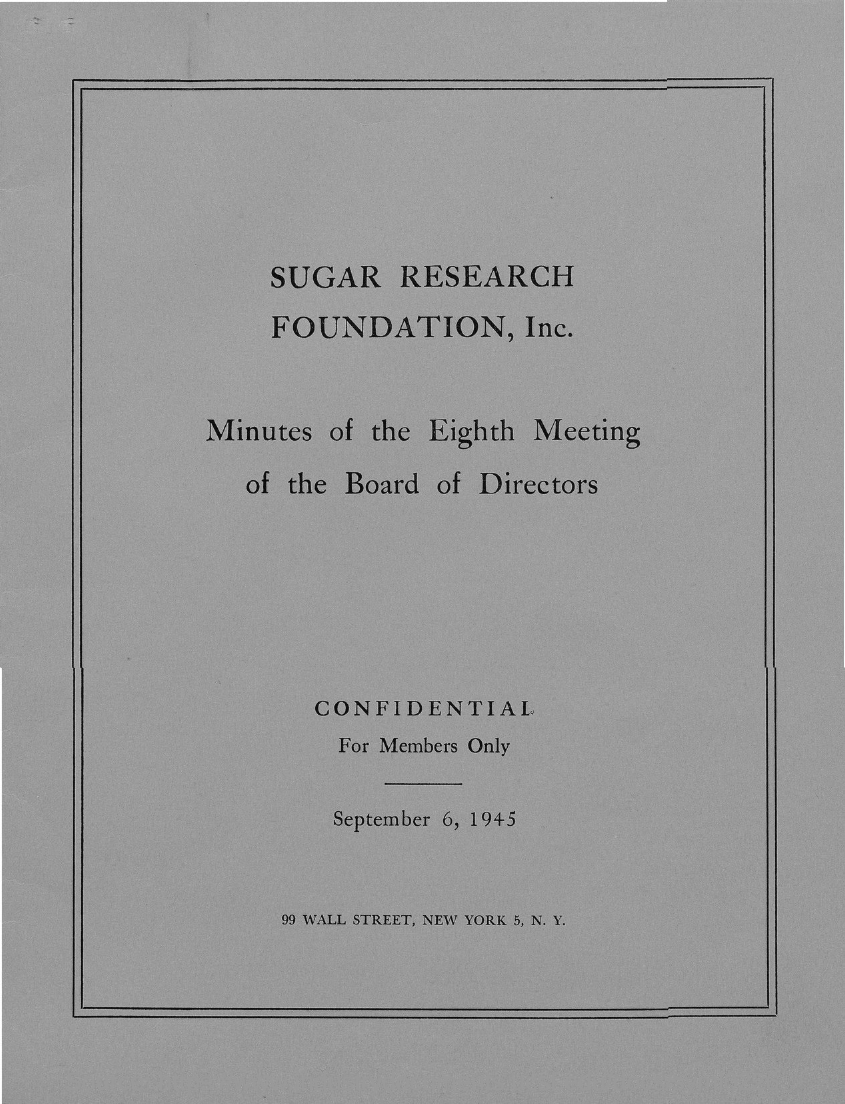Which company's minutes of the eighth meeting of the board of directors is mentioned here?
Offer a very short reply. Sugar Research Foundation, Inc. What is the date mentioned in this document?
Your response must be concise. September 6, 1945. 